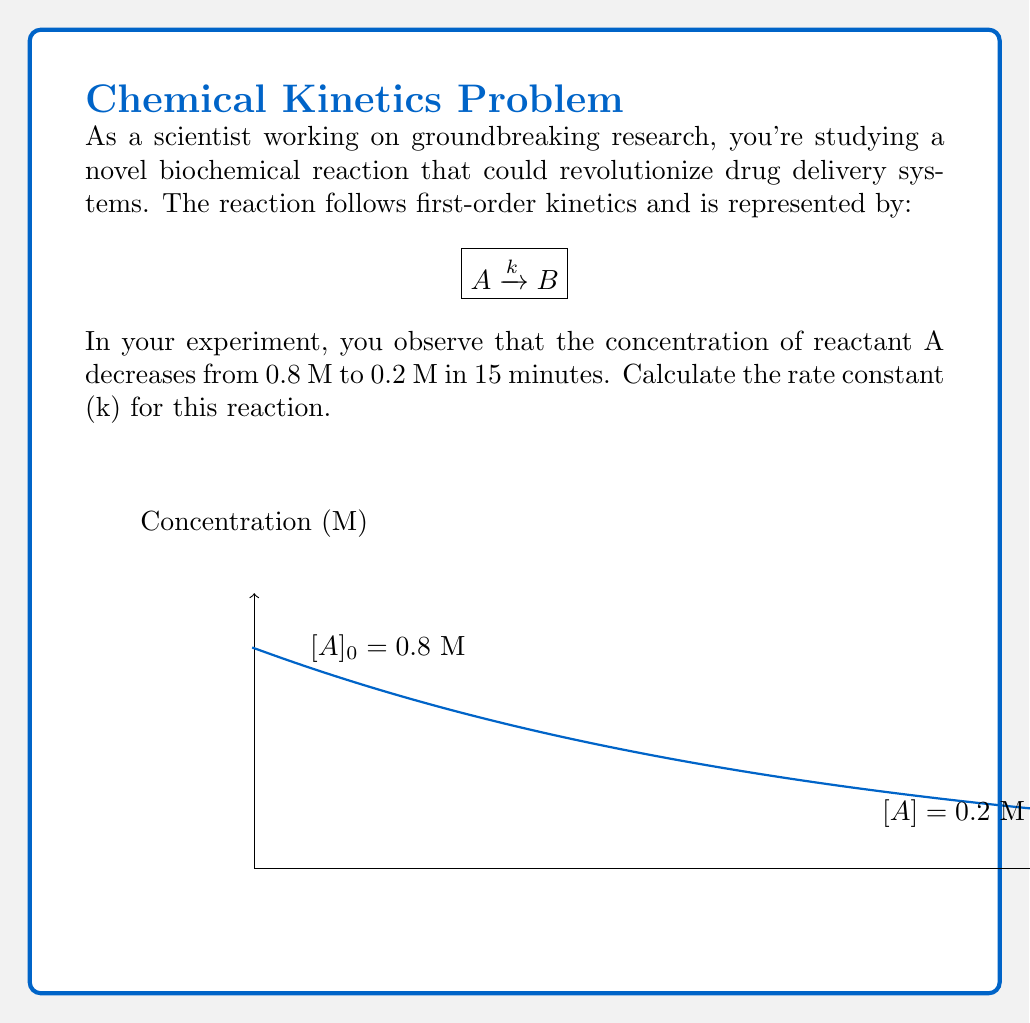Help me with this question. To solve this problem, we'll use the integrated rate law for a first-order reaction:

$$\ln[A] = -kt + \ln[A]_0$$

Where:
- $[A]$ is the concentration of A at time t
- $[A]_0$ is the initial concentration of A
- $k$ is the rate constant
- $t$ is time

Step 1: Plug in the known values
- $[A]_0 = 0.8$ M
- $[A] = 0.2$ M
- $t = 15$ minutes

Step 2: Apply the integrated rate law
$$\ln(0.2) = -k(15) + \ln(0.8)$$

Step 3: Solve for k
$$\ln(0.2) - \ln(0.8) = -15k$$
$$\ln(\frac{0.2}{0.8}) = -15k$$
$$-1.386294 = -15k$$

Step 4: Calculate k
$$k = \frac{1.386294}{15} = 0.092420 \text{ min}^{-1}$$

Therefore, the rate constant k is approximately 0.092420 min⁻¹.
Answer: $k \approx 0.092420 \text{ min}^{-1}$ 